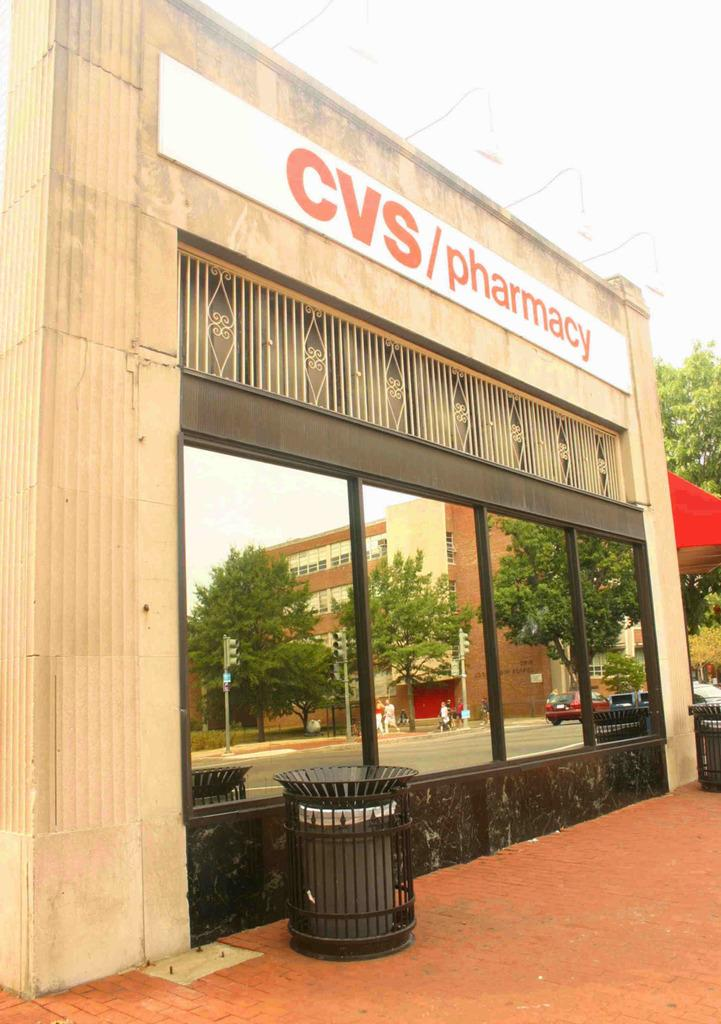<image>
Summarize the visual content of the image. The outside of a CVS/pharmacy with red brick in front 